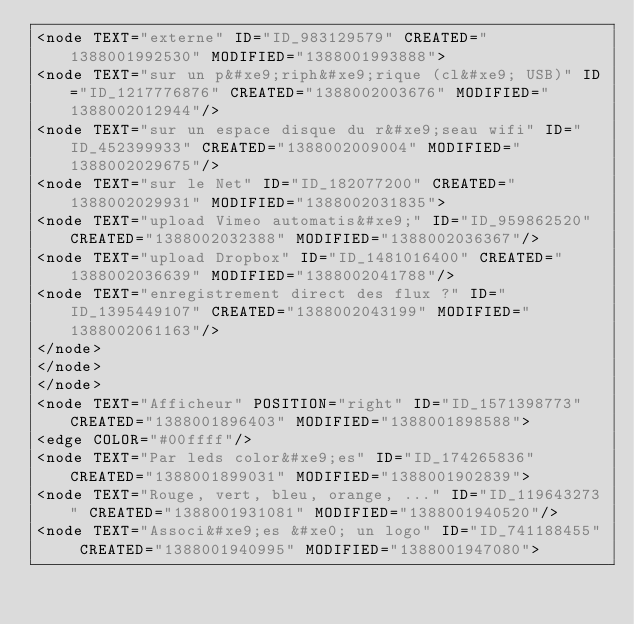Convert code to text. <code><loc_0><loc_0><loc_500><loc_500><_ObjectiveC_><node TEXT="externe" ID="ID_983129579" CREATED="1388001992530" MODIFIED="1388001993888">
<node TEXT="sur un p&#xe9;riph&#xe9;rique (cl&#xe9; USB)" ID="ID_1217776876" CREATED="1388002003676" MODIFIED="1388002012944"/>
<node TEXT="sur un espace disque du r&#xe9;seau wifi" ID="ID_452399933" CREATED="1388002009004" MODIFIED="1388002029675"/>
<node TEXT="sur le Net" ID="ID_182077200" CREATED="1388002029931" MODIFIED="1388002031835">
<node TEXT="upload Vimeo automatis&#xe9;" ID="ID_959862520" CREATED="1388002032388" MODIFIED="1388002036367"/>
<node TEXT="upload Dropbox" ID="ID_1481016400" CREATED="1388002036639" MODIFIED="1388002041788"/>
<node TEXT="enregistrement direct des flux ?" ID="ID_1395449107" CREATED="1388002043199" MODIFIED="1388002061163"/>
</node>
</node>
</node>
<node TEXT="Afficheur" POSITION="right" ID="ID_1571398773" CREATED="1388001896403" MODIFIED="1388001898588">
<edge COLOR="#00ffff"/>
<node TEXT="Par leds color&#xe9;es" ID="ID_174265836" CREATED="1388001899031" MODIFIED="1388001902839">
<node TEXT="Rouge, vert, bleu, orange, ..." ID="ID_119643273" CREATED="1388001931081" MODIFIED="1388001940520"/>
<node TEXT="Associ&#xe9;es &#xe0; un logo" ID="ID_741188455" CREATED="1388001940995" MODIFIED="1388001947080"></code> 